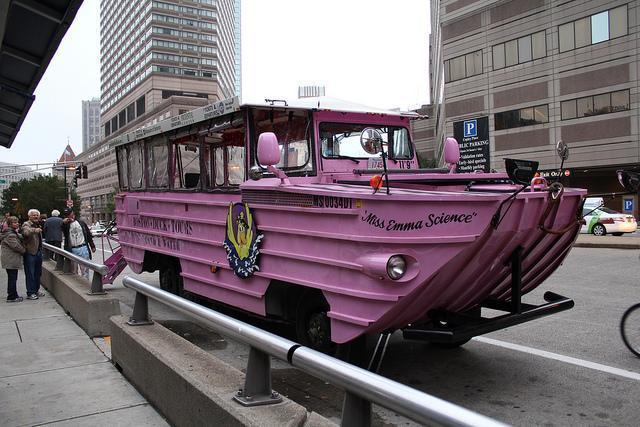Evaluate: Does the caption "The bicycle is on the boat." match the image?
Answer yes or no. No. Is this affirmation: "The boat is facing away from the bicycle." correct?
Answer yes or no. No. 